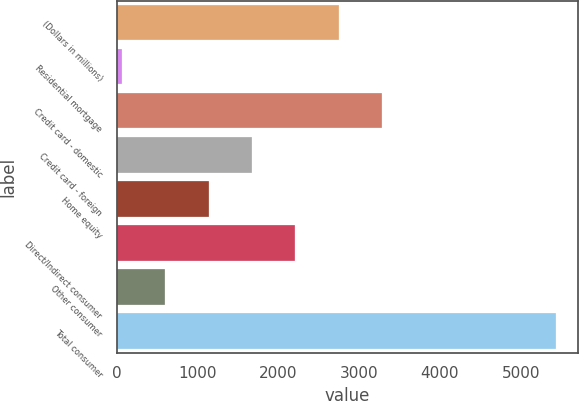Convert chart to OTSL. <chart><loc_0><loc_0><loc_500><loc_500><bar_chart><fcel>(Dollars in millions)<fcel>Residential mortgage<fcel>Credit card - domestic<fcel>Credit card - foreign<fcel>Home equity<fcel>Direct/Indirect consumer<fcel>Other consumer<fcel>Total consumer<nl><fcel>2747<fcel>59<fcel>3284.6<fcel>1671.8<fcel>1134.2<fcel>2209.4<fcel>596.6<fcel>5435<nl></chart> 